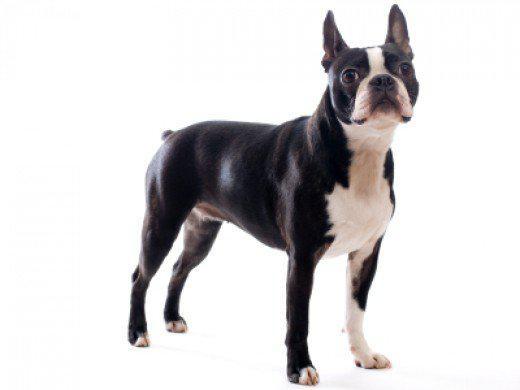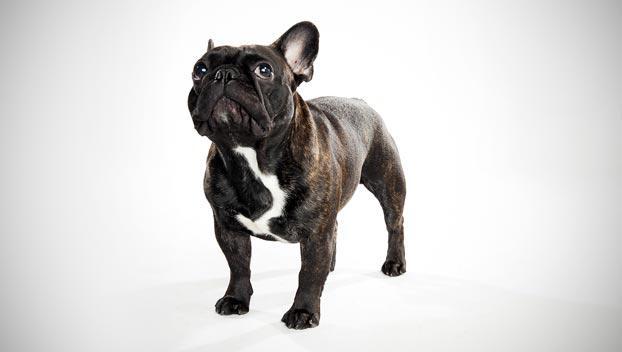The first image is the image on the left, the second image is the image on the right. Evaluate the accuracy of this statement regarding the images: "One  dog has an all-white body, excluding its head.". Is it true? Answer yes or no. No. 